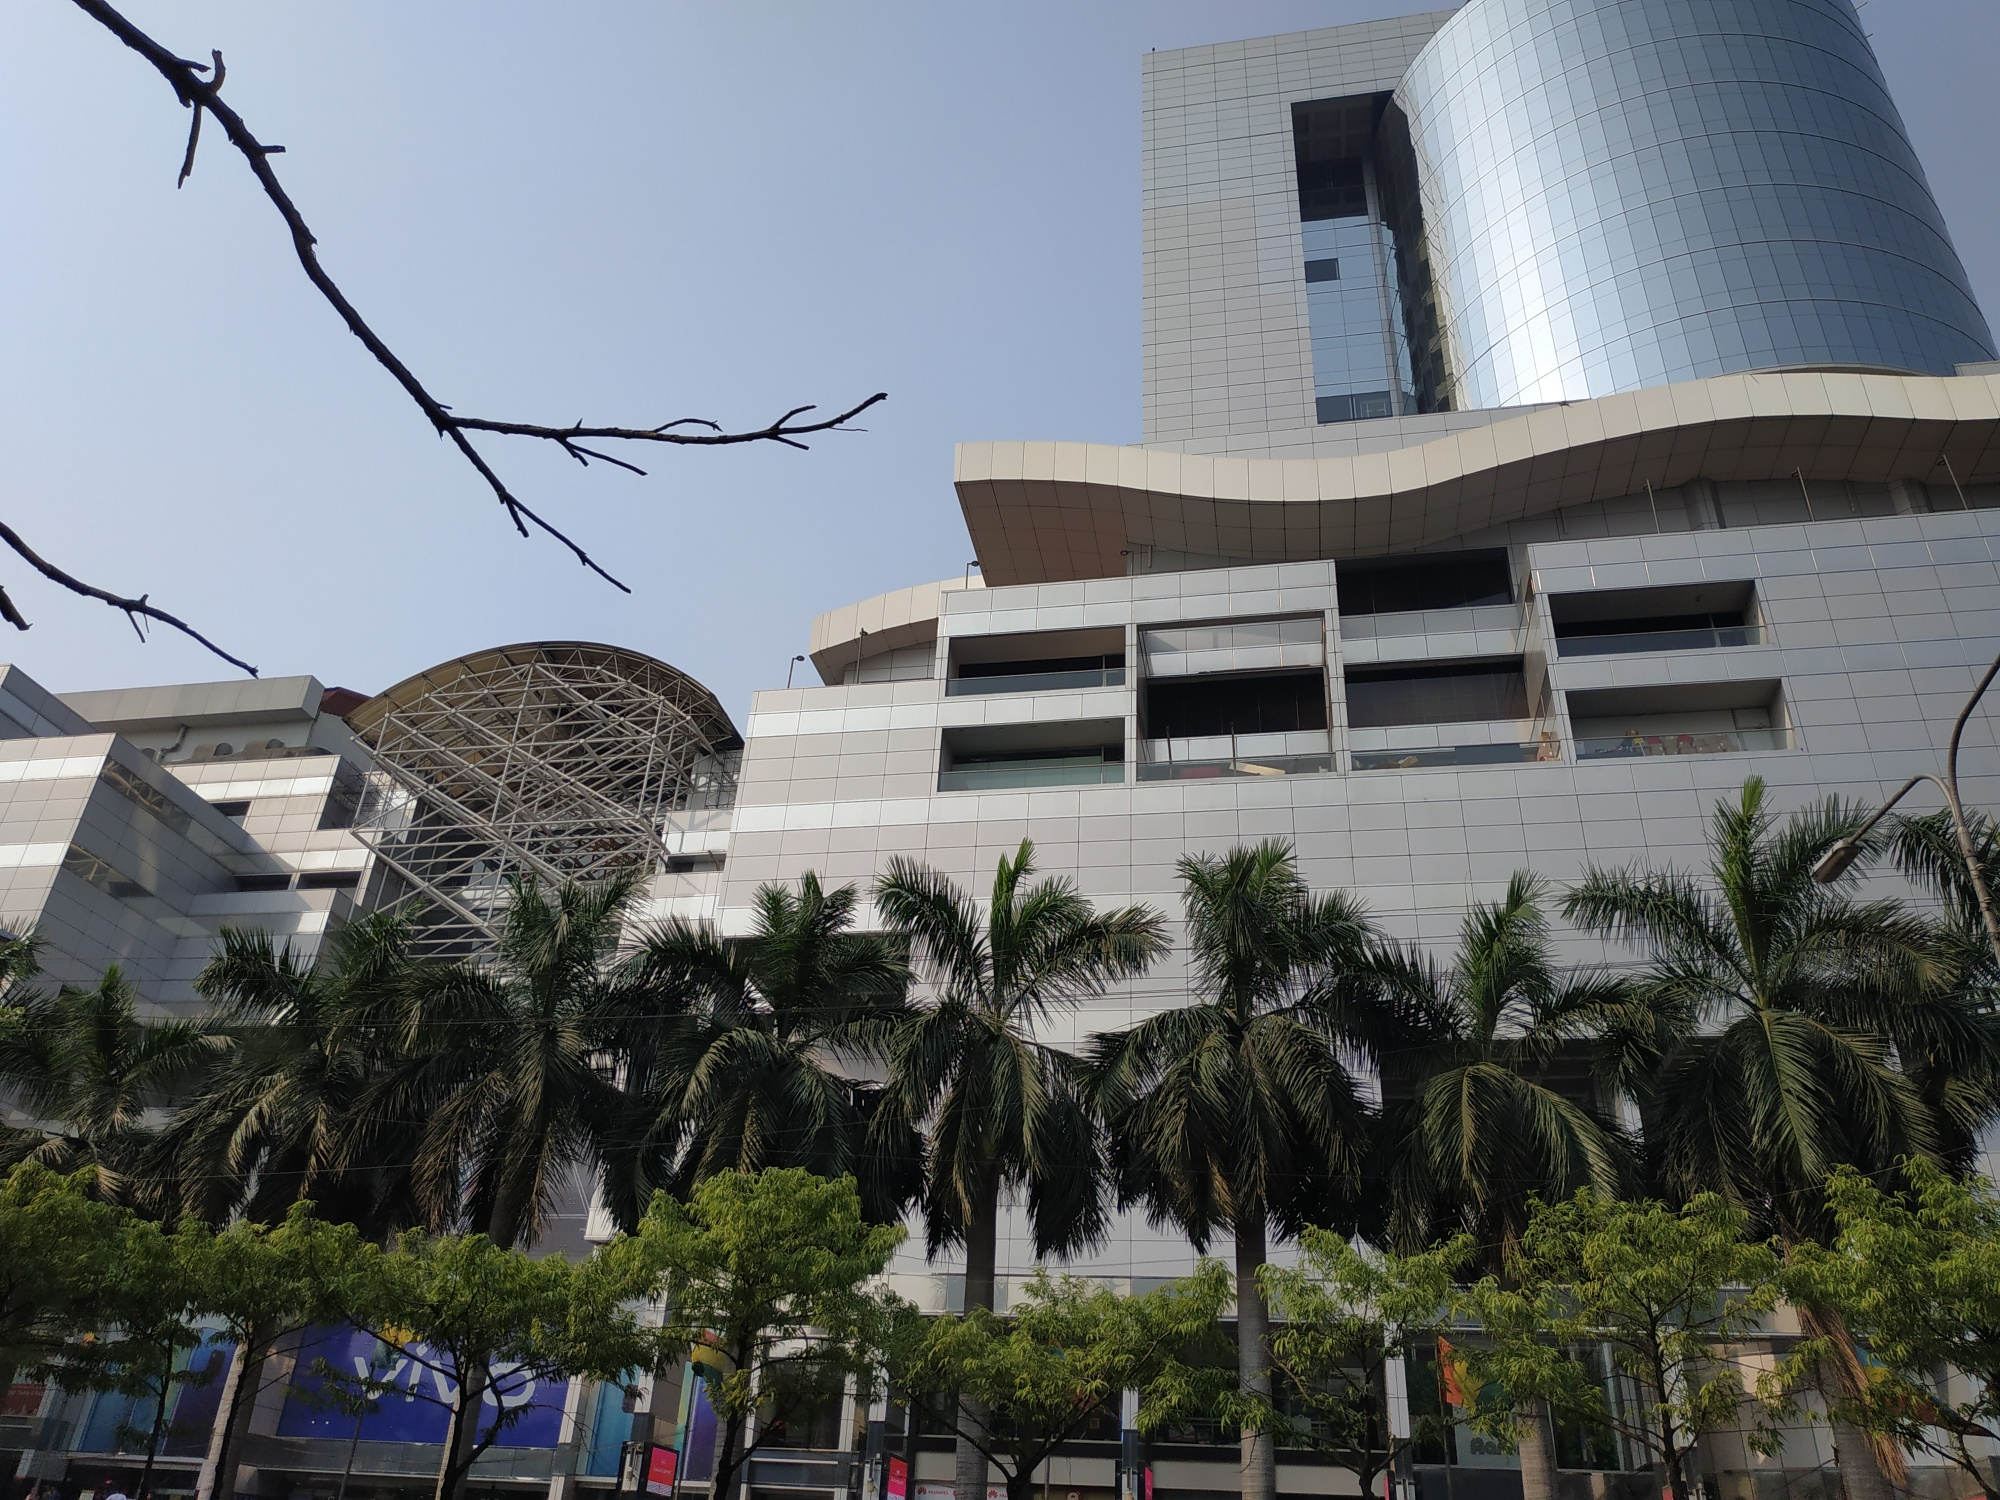What kind of events or activities would be ideal to host in this building? The unique architectural and aesthetic appeal of this building makes it ideal for hosting a variety of high-profile events and activities. The spacious and modern design is perfect for international business conferences, blending convenience with a touch of elegance. The reflective glass facade and metal dome could serve as an iconic backdrop for fashion shows, attracting elite designers and fashion enthusiasts. Art exhibitions and cultural festivals would thrive here, utilizing the open spaces and the natural light to highlight creative works. High-rise dining experiences with panoramic views could be a major attraction, offering guests a luxurious and memorable experience. Overall, the building’s design and location provide a versatile venue for a range of prestigious events and activities. 